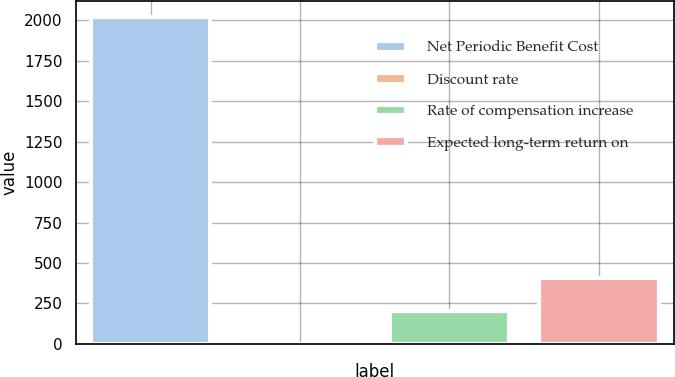<chart> <loc_0><loc_0><loc_500><loc_500><bar_chart><fcel>Net Periodic Benefit Cost<fcel>Discount rate<fcel>Rate of compensation increase<fcel>Expected long-term return on<nl><fcel>2018<fcel>1.4<fcel>203.06<fcel>404.72<nl></chart> 